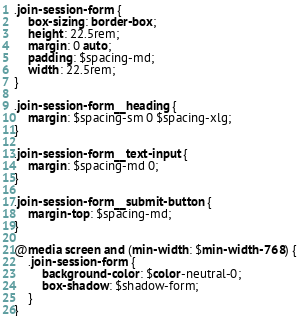Convert code to text. <code><loc_0><loc_0><loc_500><loc_500><_CSS_>.join-session-form {
    box-sizing: border-box;
    height: 22.5rem;
    margin: 0 auto;
    padding: $spacing-md;
    width: 22.5rem;
}

.join-session-form__heading {
    margin: $spacing-sm 0 $spacing-xlg;
}

.join-session-form__text-input {
    margin: $spacing-md 0;
}

.join-session-form__submit-button {
    margin-top: $spacing-md;
}

@media screen and (min-width: $min-width-768) {
    .join-session-form {
        background-color: $color-neutral-0;
        box-shadow: $shadow-form;
    }
}
</code> 